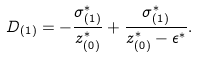<formula> <loc_0><loc_0><loc_500><loc_500>D _ { ( 1 ) } = - \frac { \sigma _ { ( 1 ) } ^ { * } } { z _ { ( 0 ) } ^ { * } } + \frac { \sigma _ { ( 1 ) } ^ { * } } { z _ { ( 0 ) } ^ { * } - \epsilon ^ { * } } .</formula> 